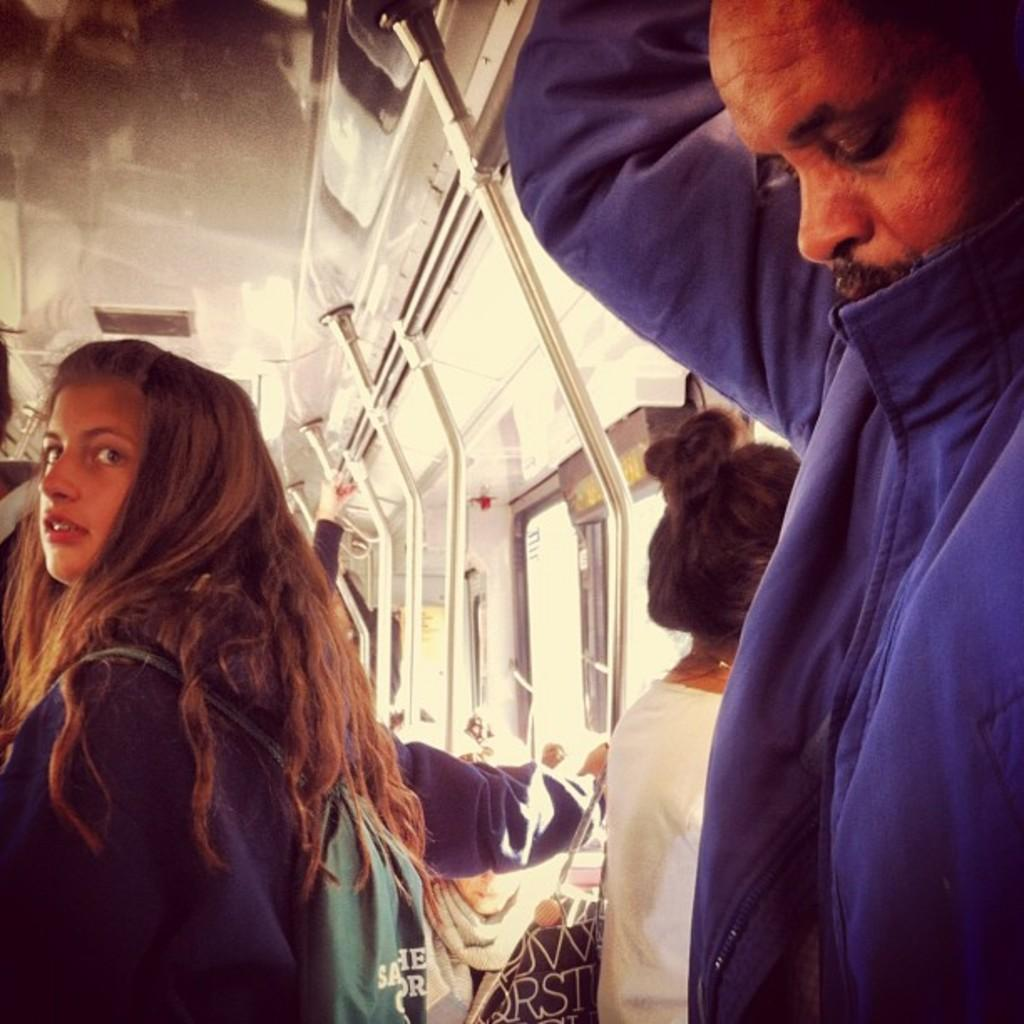Where does the image appear to be taken? The image appears to be inside a train. What are the passengers in the image doing? The passengers are standing in the train. How are the passengers supporting themselves in the image? The passengers are holding onto rods. What can be seen on the right side of the image? There are windows on the right side of the image. What type of straw is being used by the passengers in the image? There is no straw present in the image; the passengers are holding onto rods for support. Can you tell me how many pairs of shoes are visible in the image? There is no specific mention of shoes in the image, so it is not possible to determine how many pairs are visible. 